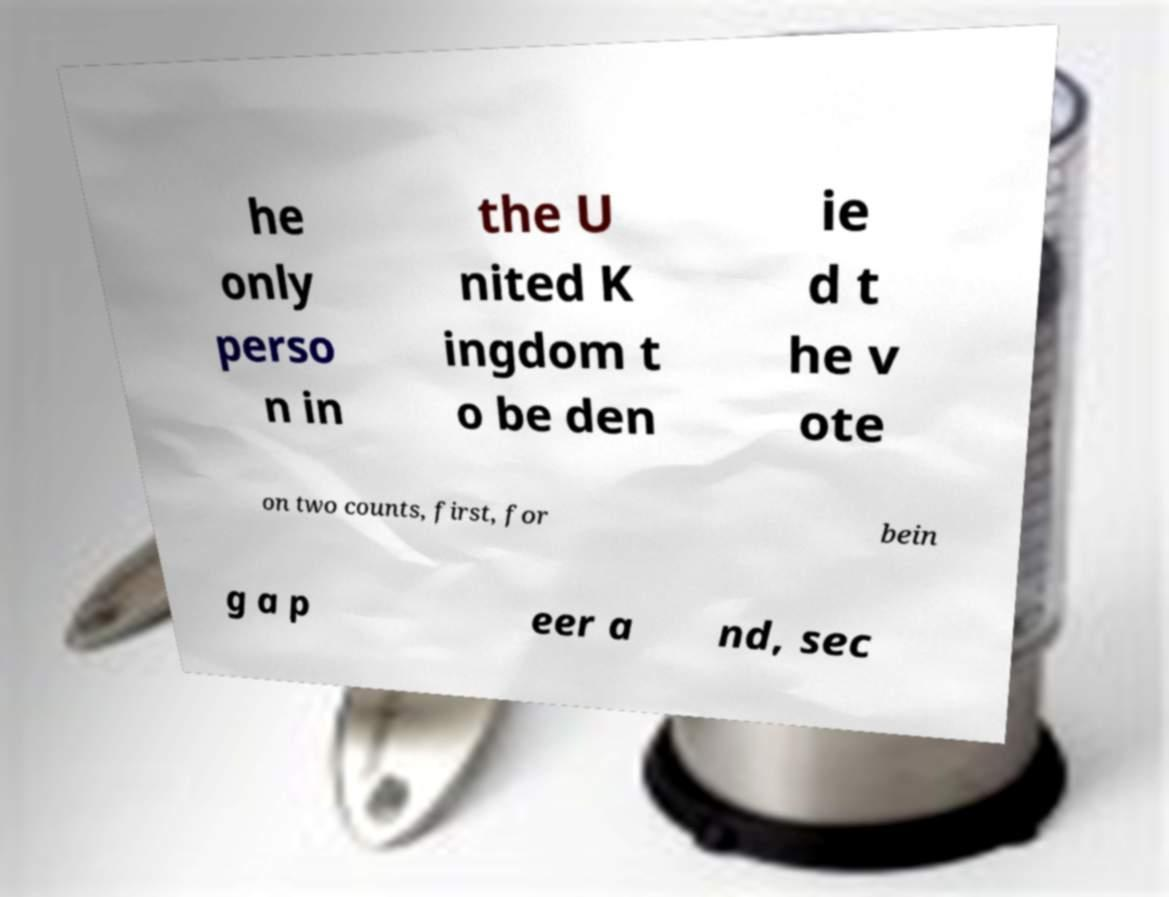Please read and relay the text visible in this image. What does it say? he only perso n in the U nited K ingdom t o be den ie d t he v ote on two counts, first, for bein g a p eer a nd, sec 